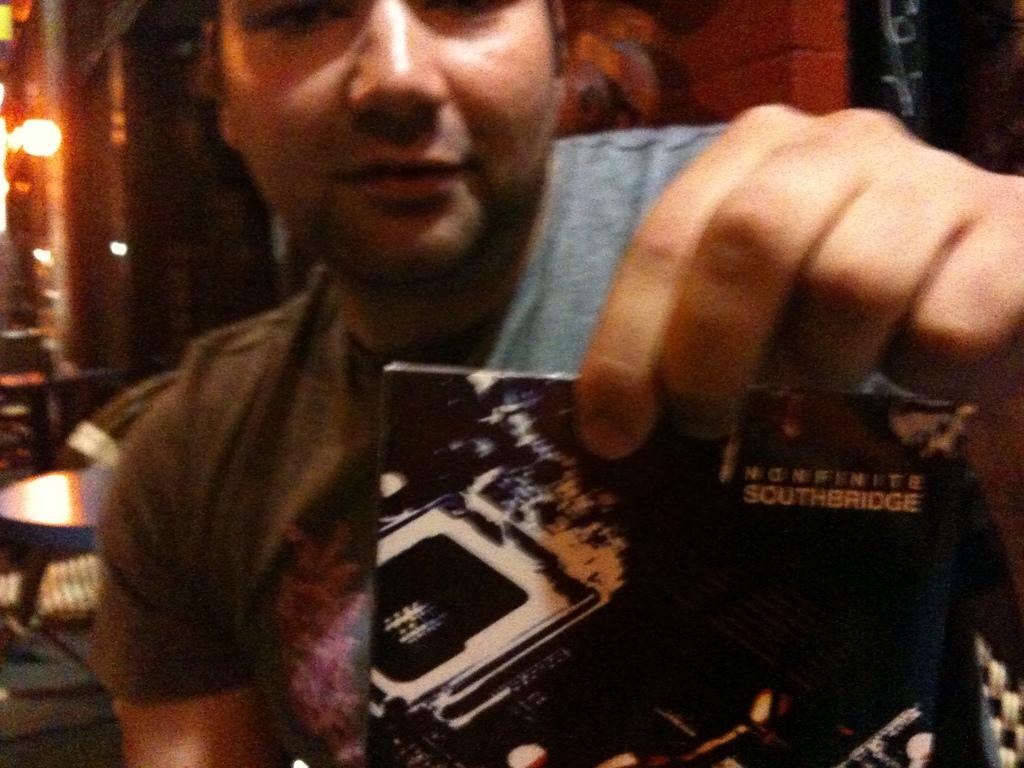In one or two sentences, can you explain what this image depicts? In this image, we can see a person sitting and holding a paper, in the background, we can see a table, wall and a light on the wall. 